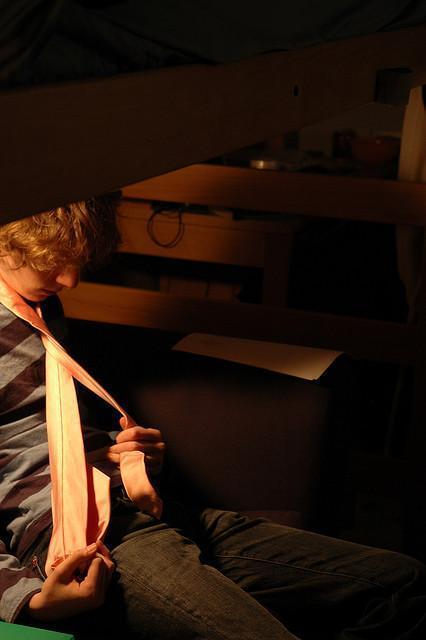How many beds are pictured?
Give a very brief answer. 1. How many people can be seen?
Give a very brief answer. 1. How many birds are in the picture?
Give a very brief answer. 0. 